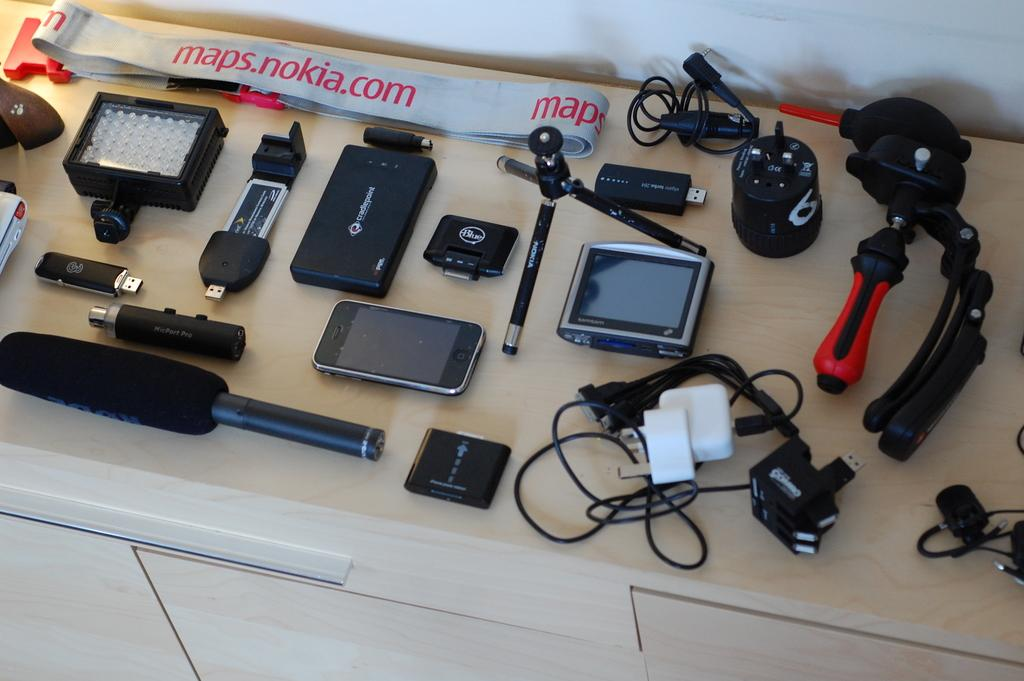<image>
Render a clear and concise summary of the photo. many tools below a maps.nokia.com site above it 